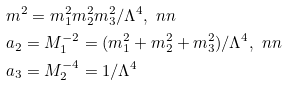Convert formula to latex. <formula><loc_0><loc_0><loc_500><loc_500>& m ^ { 2 } = m _ { 1 } ^ { 2 } m _ { 2 } ^ { 2 } m _ { 3 } ^ { 2 } / \Lambda ^ { 4 } , \ n n \\ & a _ { 2 } = M _ { 1 } ^ { - 2 } = ( m _ { 1 } ^ { 2 } + m _ { 2 } ^ { 2 } + m _ { 3 } ^ { 2 } ) / \Lambda ^ { 4 } , \ n n \\ & a _ { 3 } = M _ { 2 } ^ { - 4 } = 1 / \Lambda ^ { 4 }</formula> 